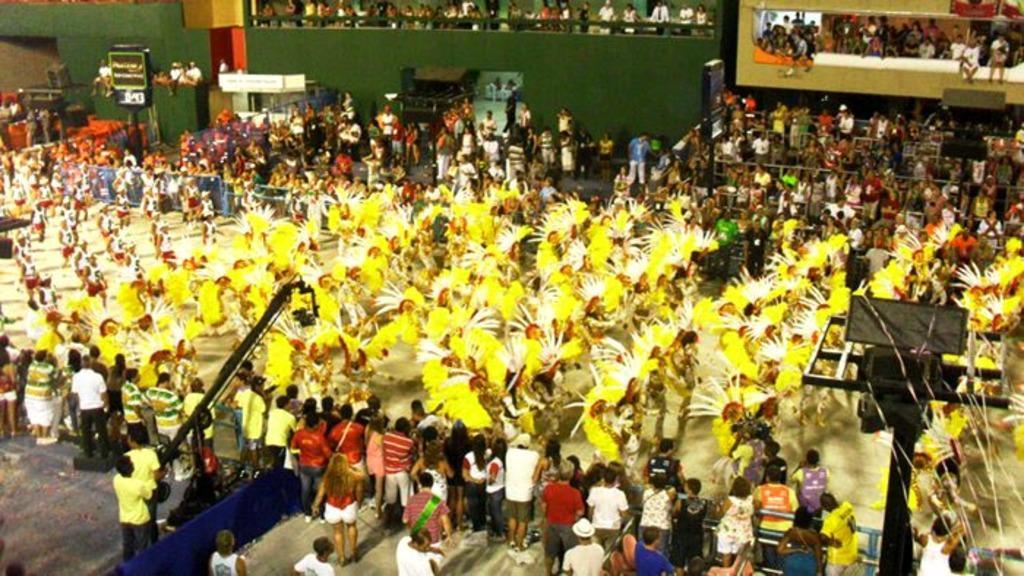How would you summarize this image in a sentence or two? This picture is taken in a stadium. In the center, there are some people wearing yellow costumes. Around them there are people watching them. At the bottom left there is a camera attached to the small crane. Towards the right bottom there is a pole. 